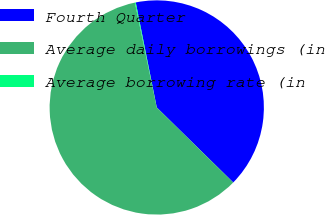<chart> <loc_0><loc_0><loc_500><loc_500><pie_chart><fcel>Fourth Quarter<fcel>Average daily borrowings (in<fcel>Average borrowing rate (in<nl><fcel>40.49%<fcel>59.38%<fcel>0.13%<nl></chart> 